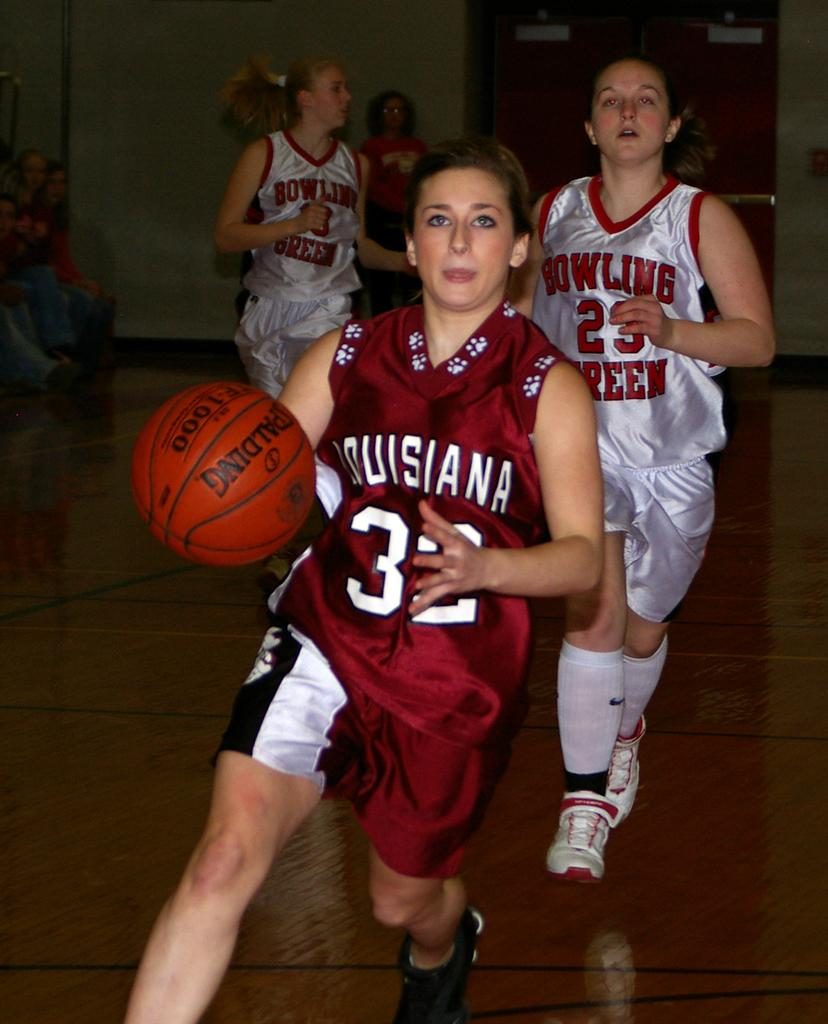<image>
Provide a brief description of the given image. A girls game of basketball is underway, player 32 is in possession of the ball. 